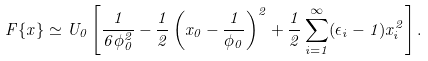<formula> <loc_0><loc_0><loc_500><loc_500>F \{ x \} \simeq U _ { 0 } \left [ \frac { 1 } { 6 \phi _ { 0 } ^ { 2 } } - \frac { 1 } { 2 } \left ( x _ { 0 } - \frac { 1 } { \phi _ { 0 } } \right ) ^ { 2 } + \frac { 1 } { 2 } \sum _ { i = 1 } ^ { \infty } ( \epsilon _ { i } - 1 ) x _ { i } ^ { 2 } \right ] .</formula> 